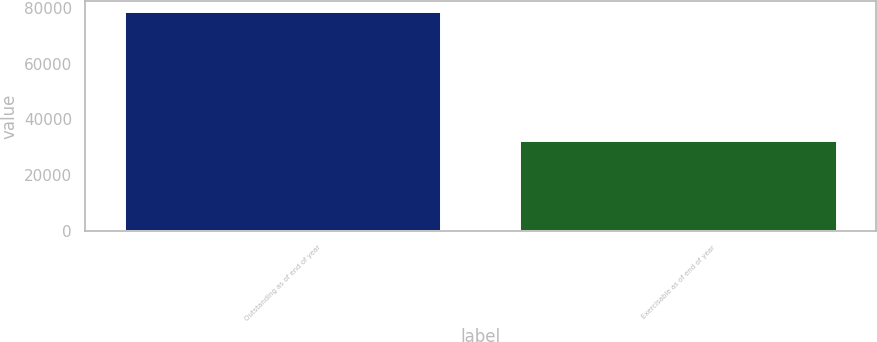Convert chart to OTSL. <chart><loc_0><loc_0><loc_500><loc_500><bar_chart><fcel>Outstanding as of end of year<fcel>Exercisable as of end of year<nl><fcel>78438<fcel>32195<nl></chart> 